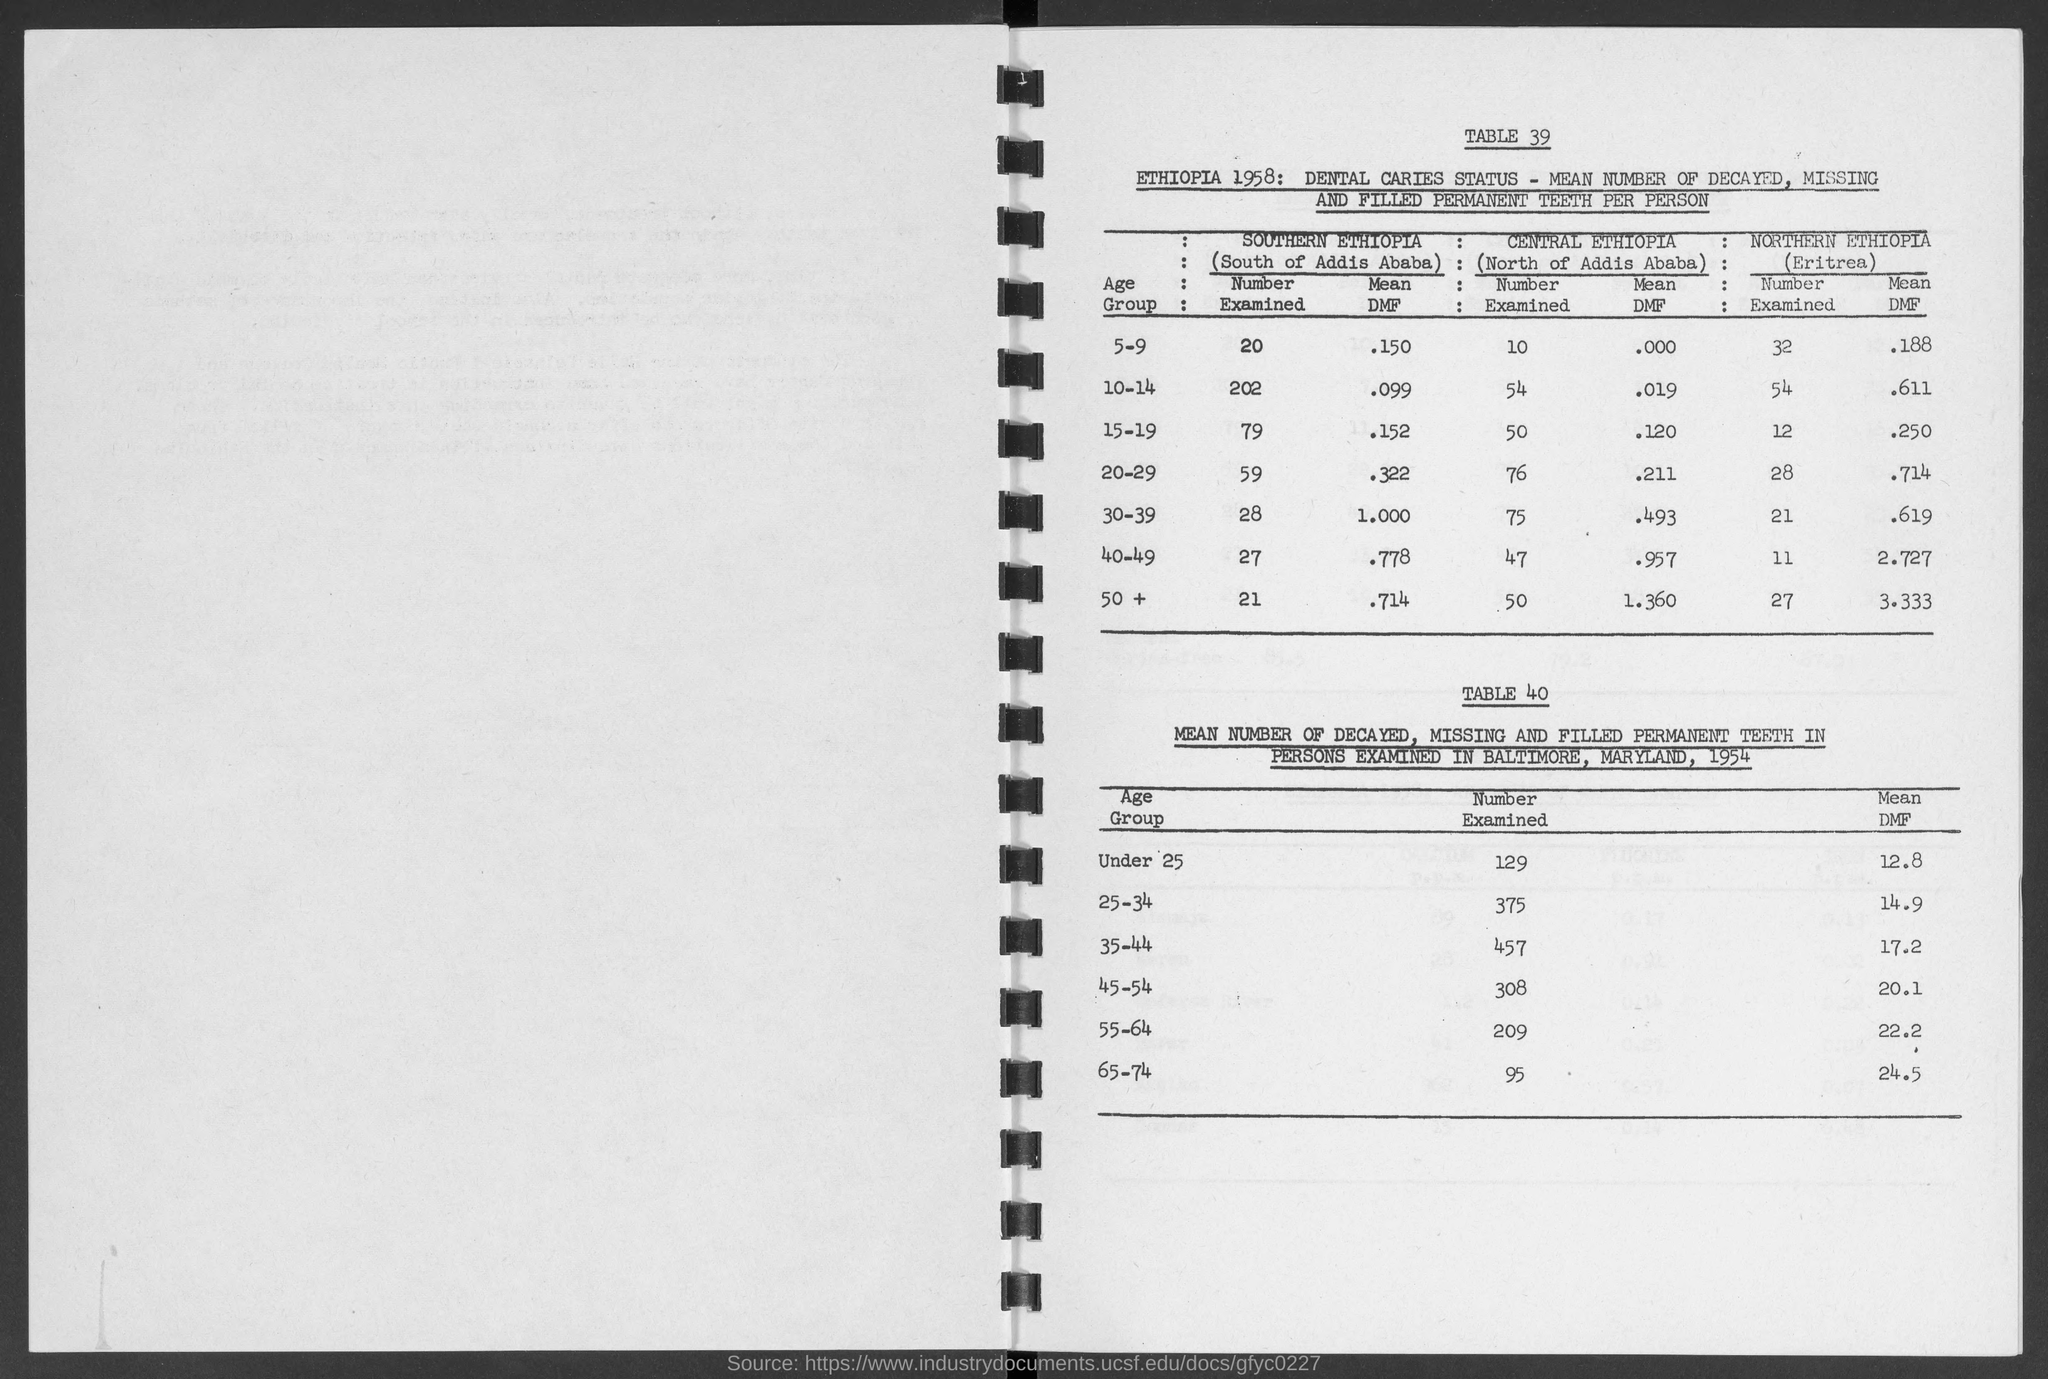Point out several critical features in this image. The mean DMF (dental mobility index) in southern Ethiopia for individuals aged 15-19 is 0.152. A study examined the prevalence of diabetes in southern Ethiopia among individuals aged 50 and older. The results showed that 21% of this age group had been diagnosed with diabetes. There is a study in southern Ethiopia that examines the number of people in the age group of 30-39. The exact number is 28. In southern Ethiopia, an examination of the number of individuals in the age group of 40-49 was conducted, and the result was 27. The mean DMF (dental mobility score) in southern Ethiopia for children aged 5-9 is approximately 0.150. 